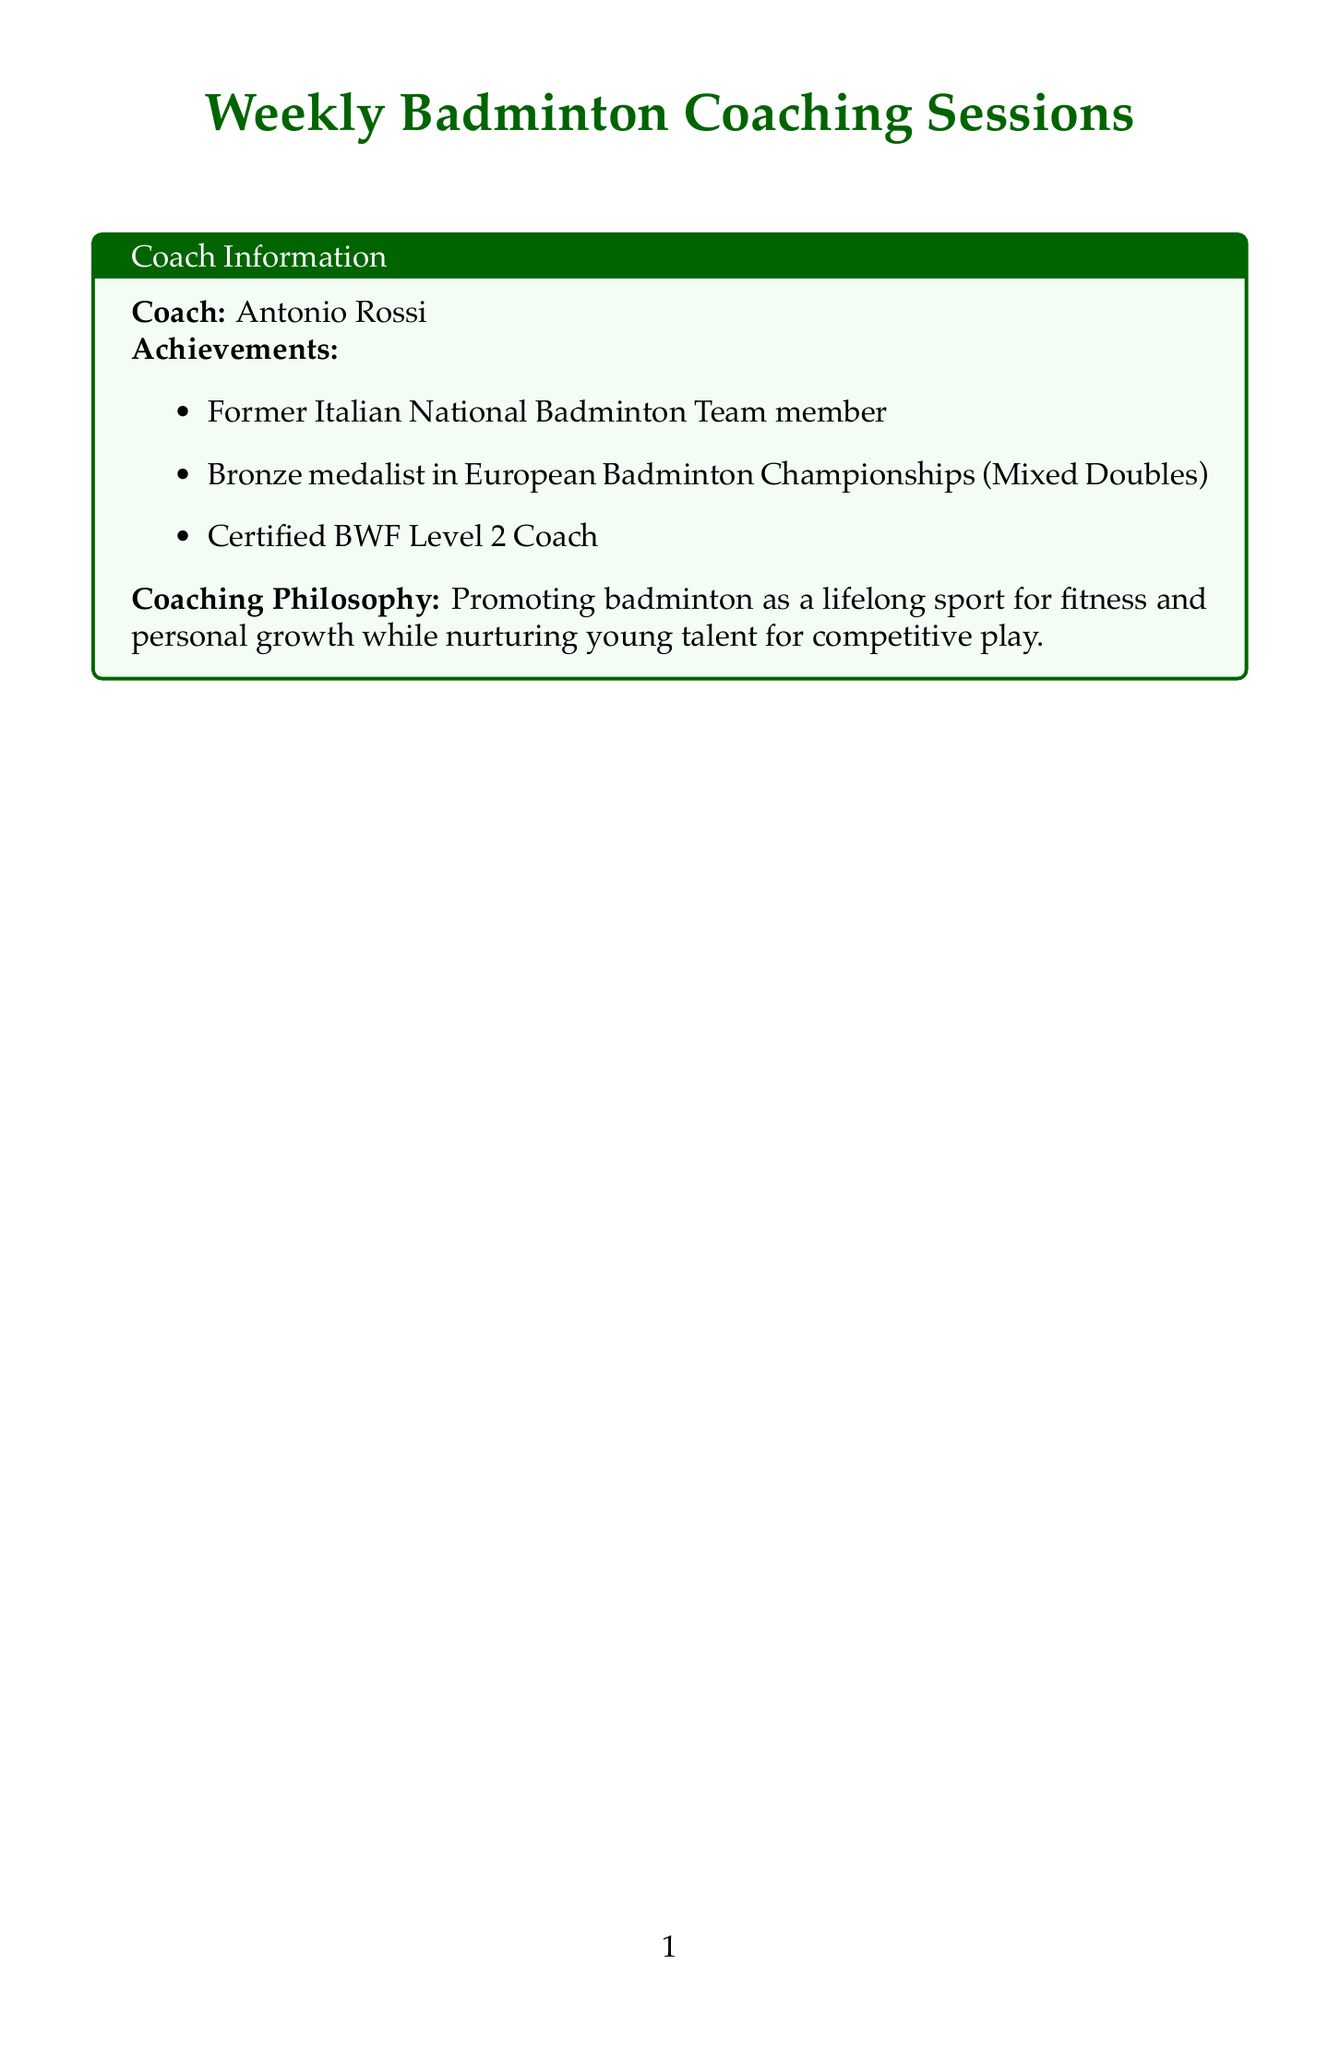What is the coaching topic for week 1? The coaching topic for week 1 is the initial introduction to badminton, which includes basic concepts about the sport.
Answer: Introduction to Badminton Who is the coach for these sessions? The coach's name is provided in the document along with their qualifications and experience.
Answer: Antonio Rossi What equipment is needed for serving techniques? The document lists specific equipment required for week 3's focus on serving techniques.
Answer: Victor Champion No. 1 shuttlecocks, Service height measurement tool How many weeks are included in the coaching schedule? The document outlines an eight-week program for badminton coaching sessions.
Answer: 8 What lesson plan topic covers net play? This question relates to the week focused on playing at the net, including specific tactics and techniques.
Answer: Net Play and Tactics What is Coach Antonio Rossi's coaching philosophy? The document describes the coach's philosophy regarding his approach to teaching badminton.
Answer: Promoting badminton as a lifelong sport for fitness and personal growth while nurturing young talent for competitive play Which week focuses on backhand strokes? The specific week devoted to practicing backhand techniques is mentioned in the document.
Answer: Week 5 What type of content can you find in the additional resources? The document lists various types of resources to support the coaching sessions and aid learning.
Answer: Reference material, Motivational content, Health guidance, Community engagement 